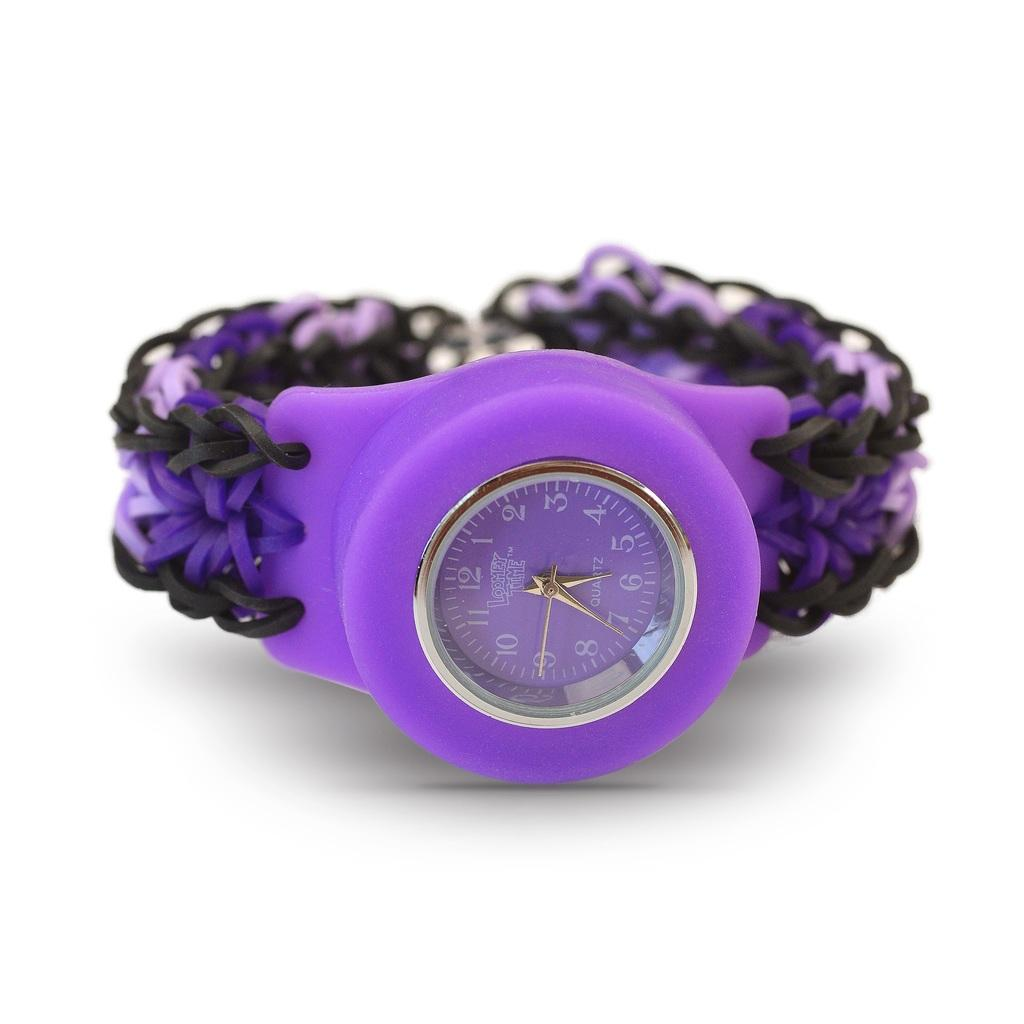<image>
Create a compact narrative representing the image presented. A purple Loomy Time quartz wristwatch with a comfortable stretchy band. 